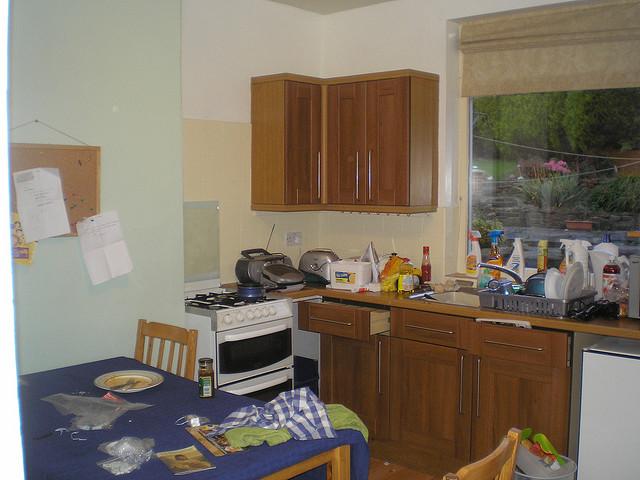What color is the bottom tablecloth?
Quick response, please. Blue. Where is pink object?
Be succinct. Outside. What color is the tablecloth?
Concise answer only. Blue. Do drawers left in this state have the potential to be a safety hazard?
Keep it brief. Yes. 